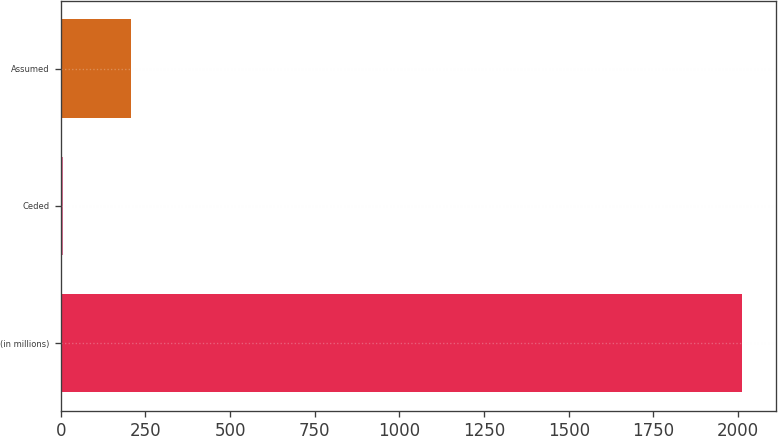Convert chart. <chart><loc_0><loc_0><loc_500><loc_500><bar_chart><fcel>(in millions)<fcel>Ceded<fcel>Assumed<nl><fcel>2012<fcel>7<fcel>207.5<nl></chart> 